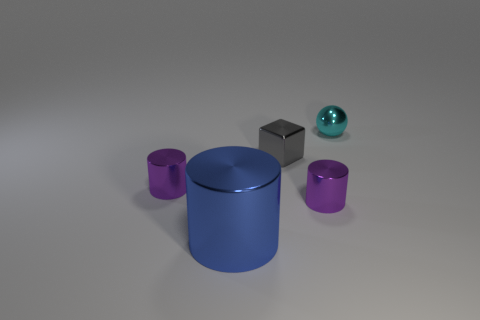What number of brown things are small blocks or cylinders?
Your answer should be very brief. 0. There is a cylinder that is to the left of the tiny gray cube and behind the big blue metal cylinder; what color is it?
Give a very brief answer. Purple. How many tiny objects are purple cylinders or metal cylinders?
Offer a very short reply. 2. What is the shape of the small gray shiny object?
Make the answer very short. Cube. Are the big blue thing and the small purple cylinder right of the small gray cube made of the same material?
Offer a very short reply. Yes. How many metal objects are either small cyan spheres or purple objects?
Make the answer very short. 3. There is a purple metal cylinder that is to the right of the large blue metallic object; what size is it?
Your response must be concise. Small. There is a blue cylinder that is made of the same material as the tiny gray thing; what is its size?
Your response must be concise. Large. Is there a big shiny cylinder?
Provide a succinct answer. Yes. Do the cyan shiny object and the small shiny thing left of the big object have the same shape?
Your answer should be very brief. No. 